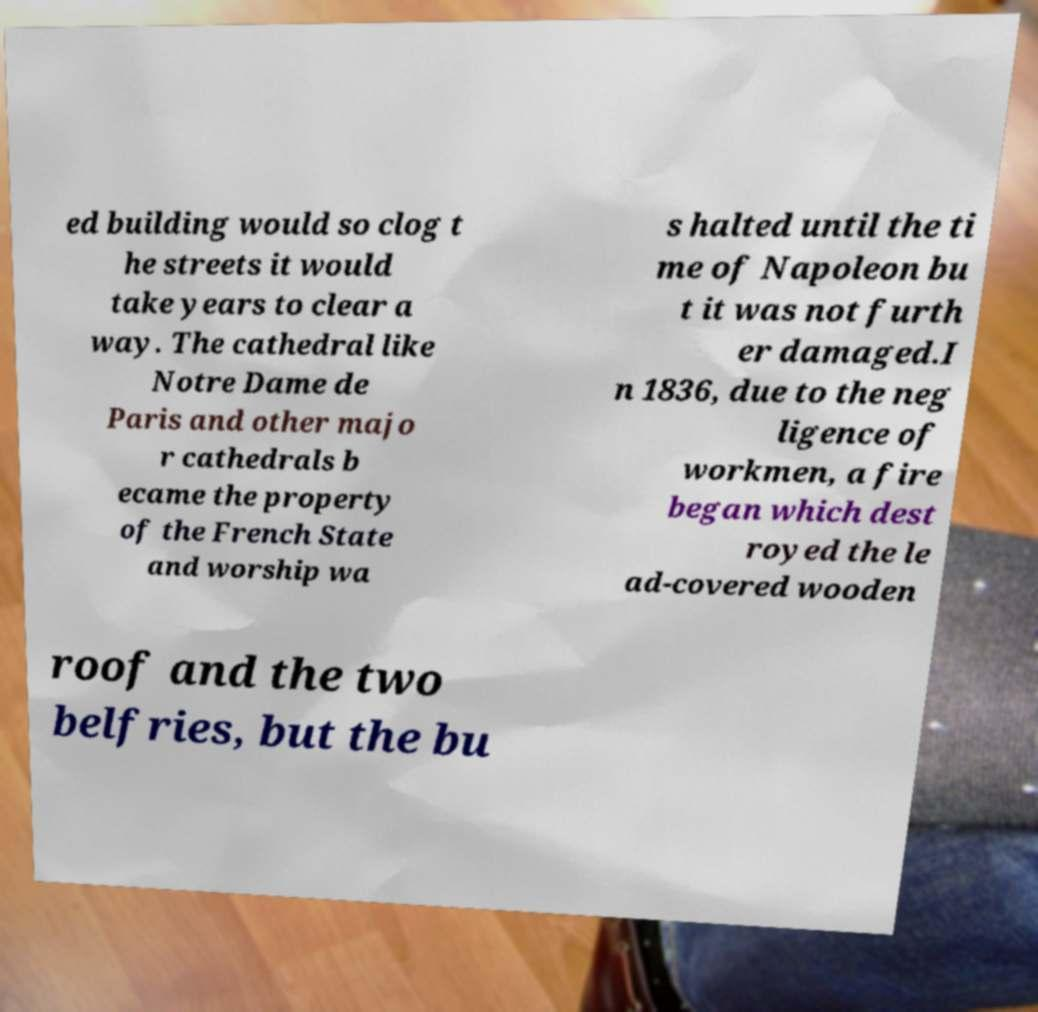Can you accurately transcribe the text from the provided image for me? ed building would so clog t he streets it would take years to clear a way. The cathedral like Notre Dame de Paris and other majo r cathedrals b ecame the property of the French State and worship wa s halted until the ti me of Napoleon bu t it was not furth er damaged.I n 1836, due to the neg ligence of workmen, a fire began which dest royed the le ad-covered wooden roof and the two belfries, but the bu 